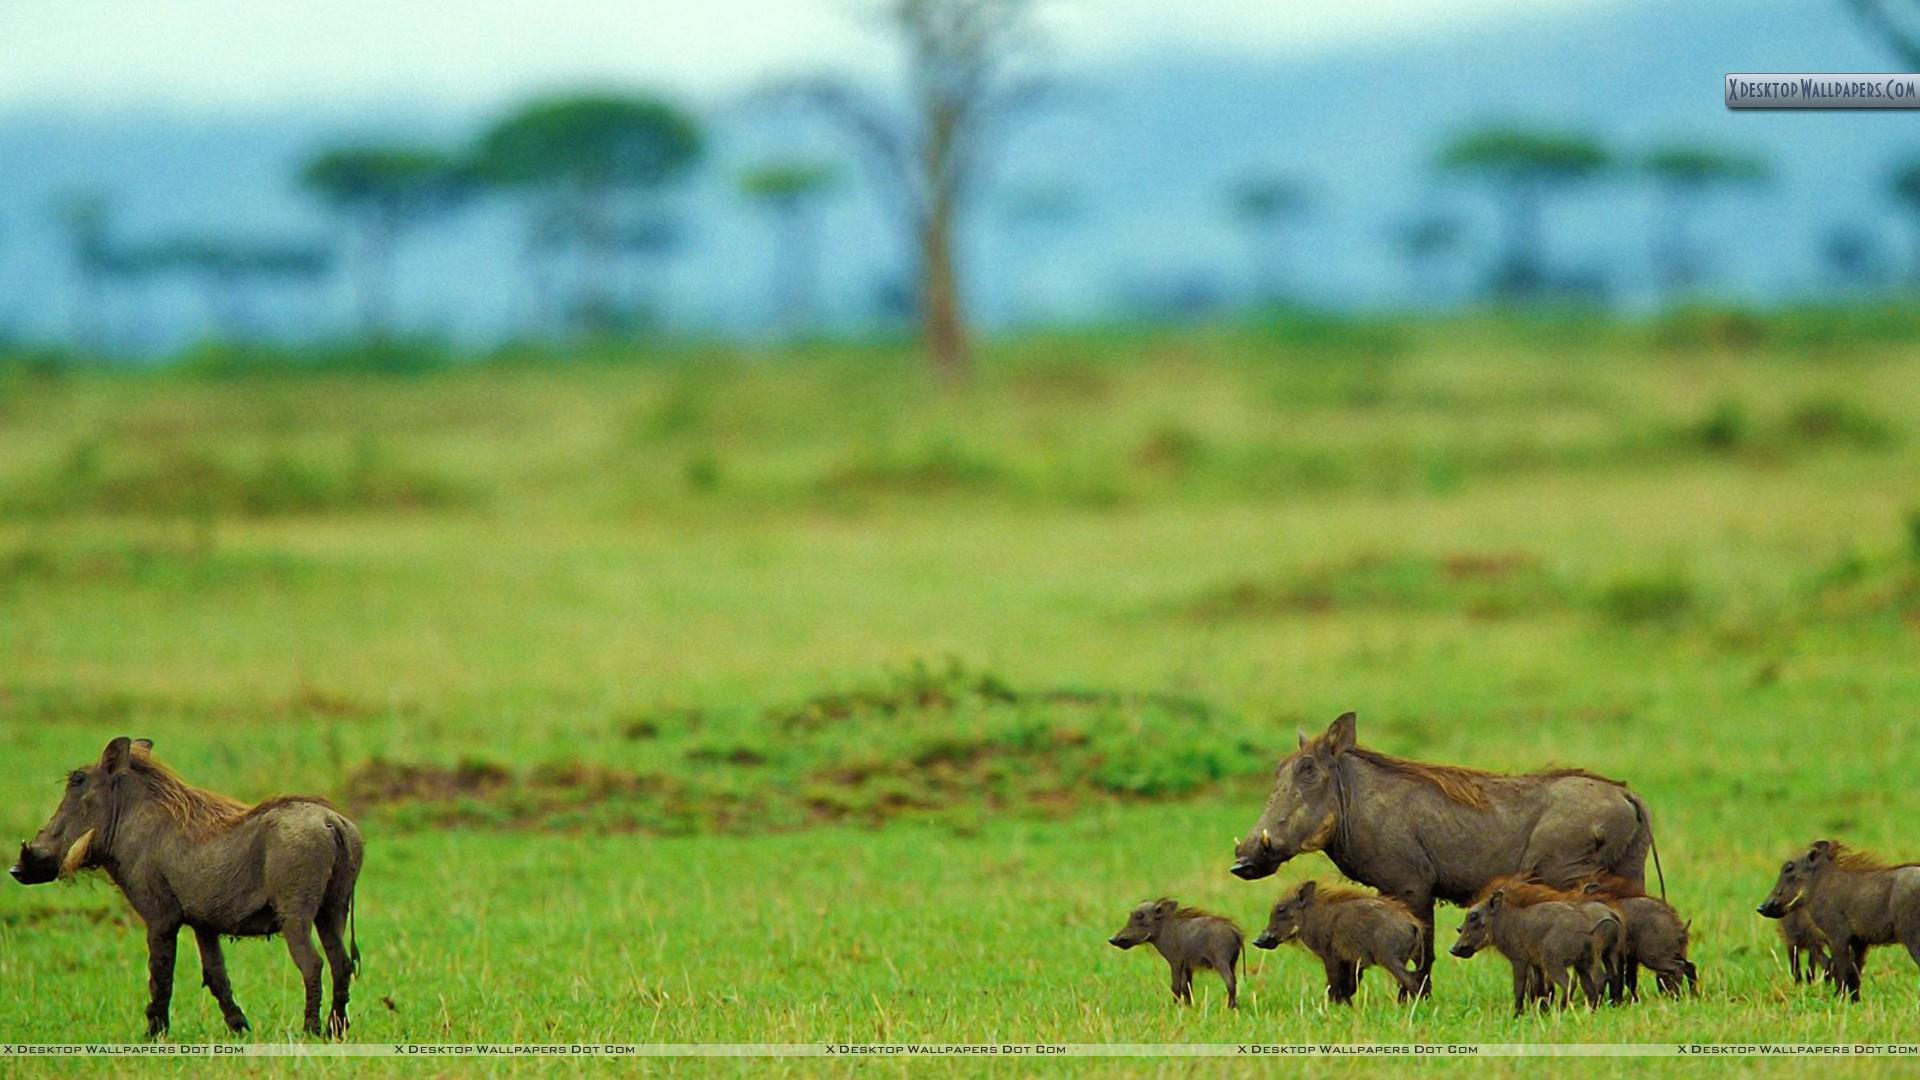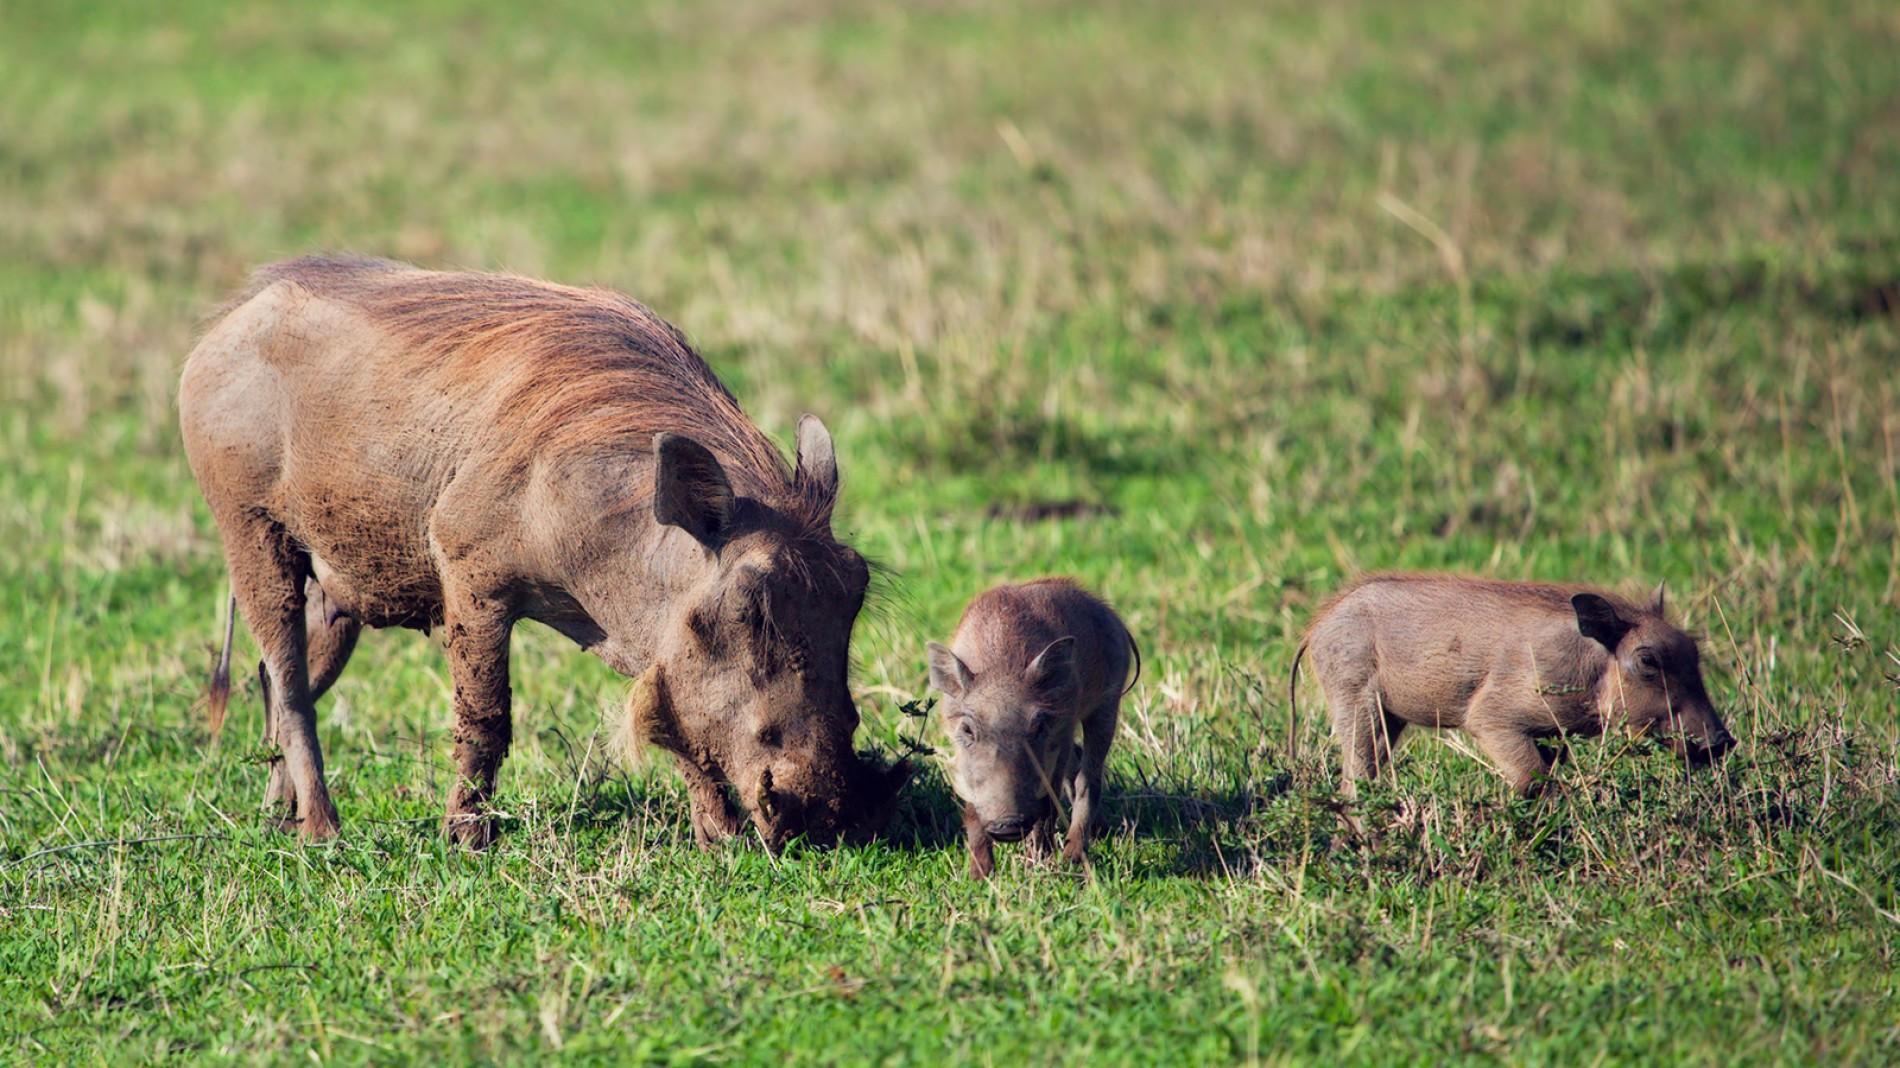The first image is the image on the left, the second image is the image on the right. Evaluate the accuracy of this statement regarding the images: "At least one image shows animals running away from the camera.". Is it true? Answer yes or no. No. 